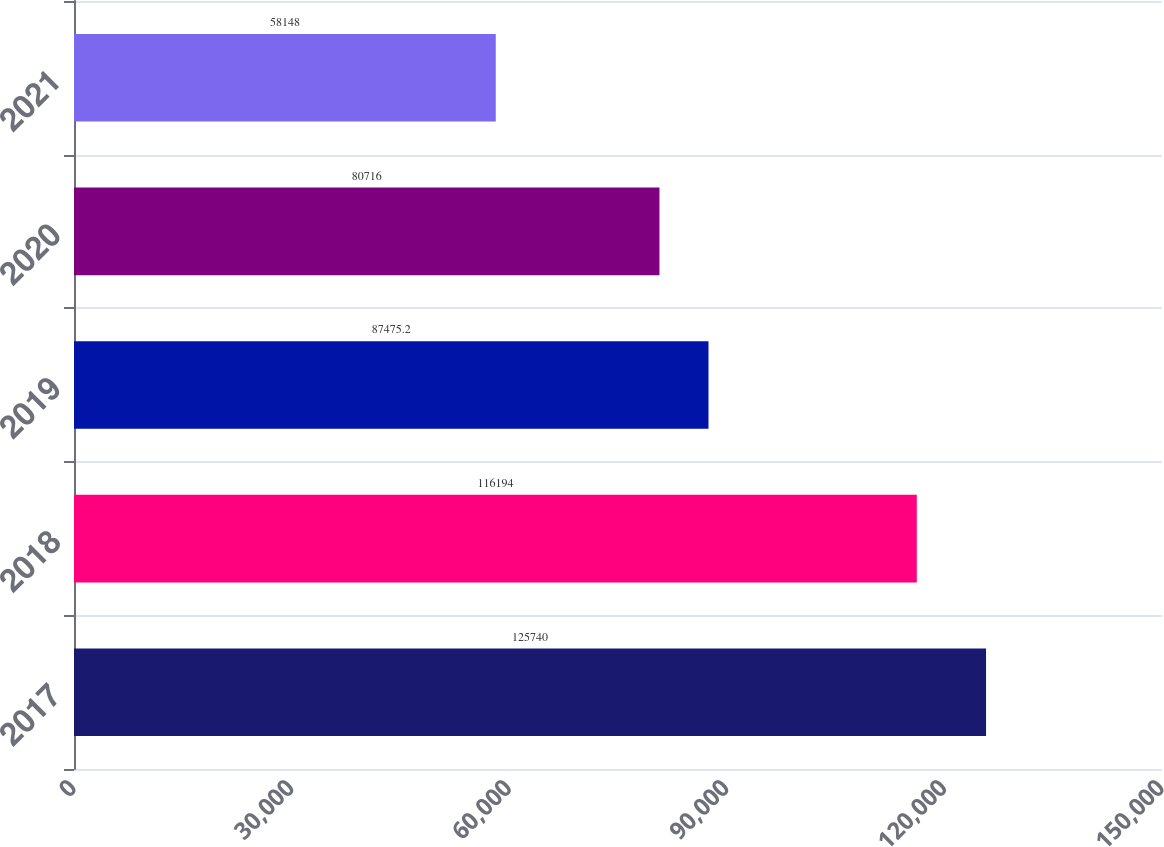Convert chart to OTSL. <chart><loc_0><loc_0><loc_500><loc_500><bar_chart><fcel>2017<fcel>2018<fcel>2019<fcel>2020<fcel>2021<nl><fcel>125740<fcel>116194<fcel>87475.2<fcel>80716<fcel>58148<nl></chart> 